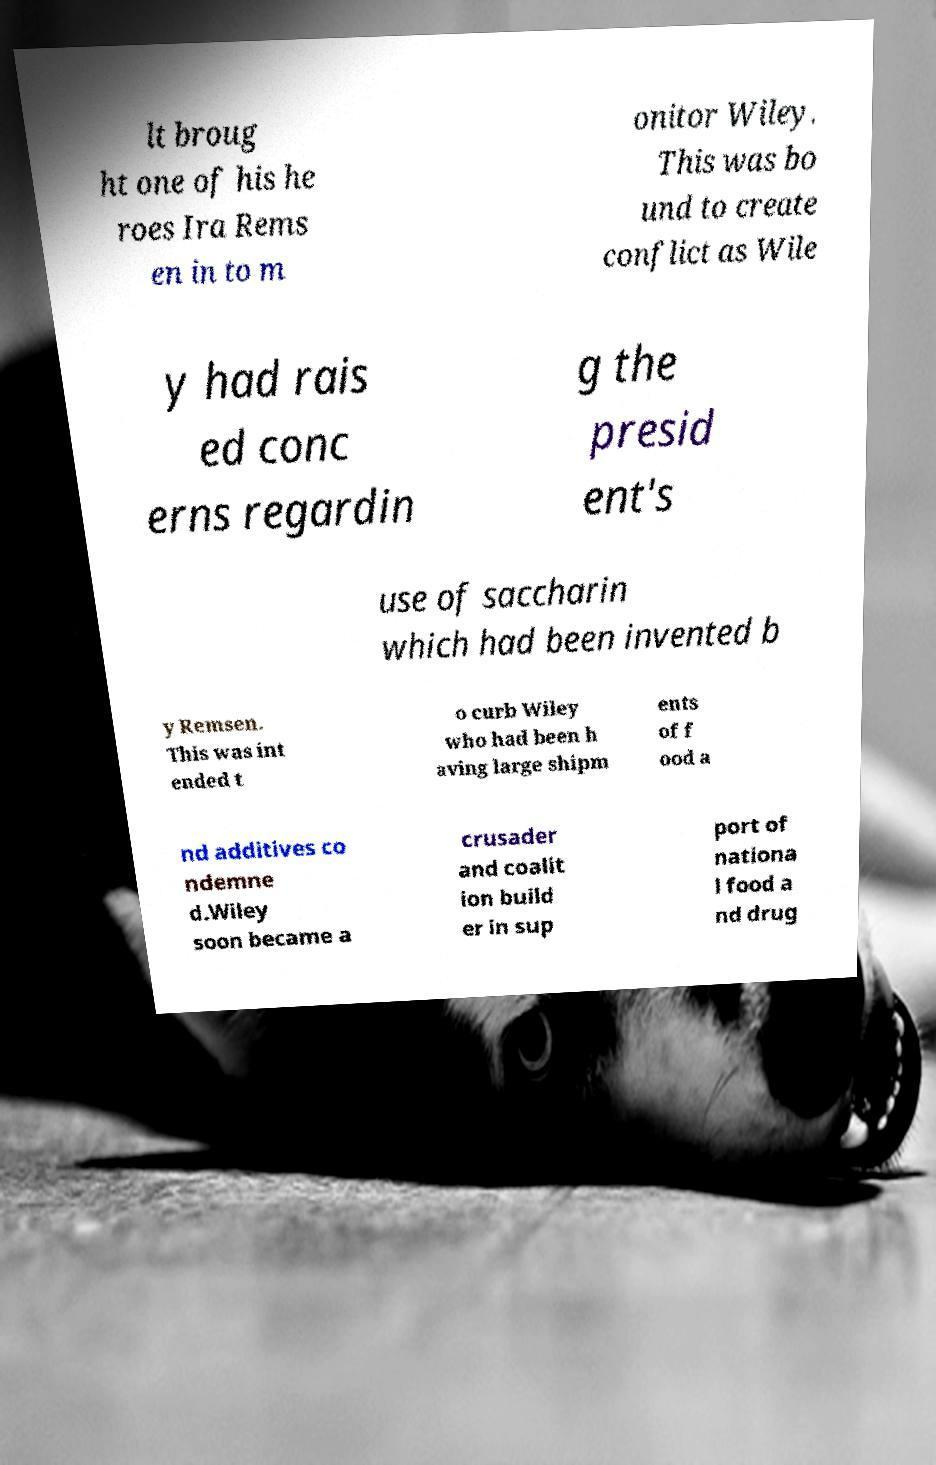Can you accurately transcribe the text from the provided image for me? lt broug ht one of his he roes Ira Rems en in to m onitor Wiley. This was bo und to create conflict as Wile y had rais ed conc erns regardin g the presid ent's use of saccharin which had been invented b y Remsen. This was int ended t o curb Wiley who had been h aving large shipm ents of f ood a nd additives co ndemne d.Wiley soon became a crusader and coalit ion build er in sup port of nationa l food a nd drug 